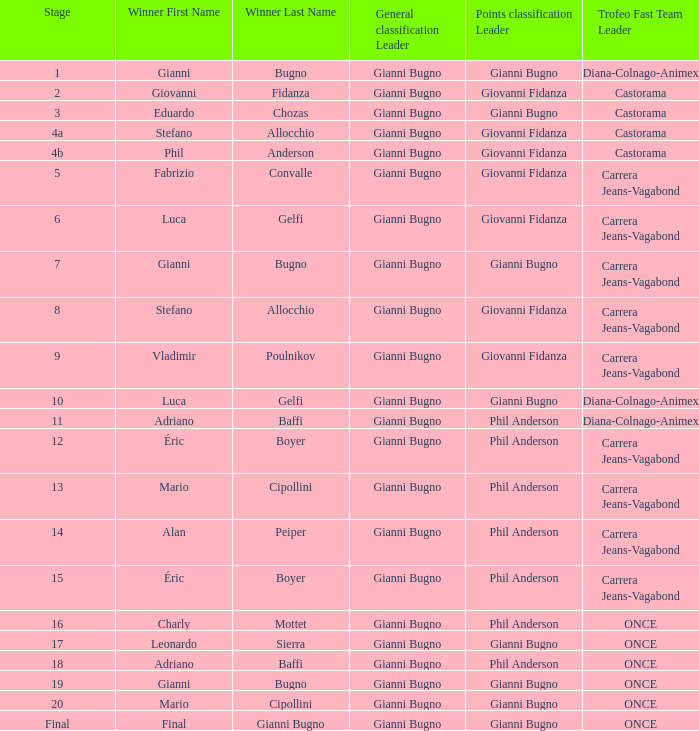What is the level when the champion is charly mottet? 16.0. 